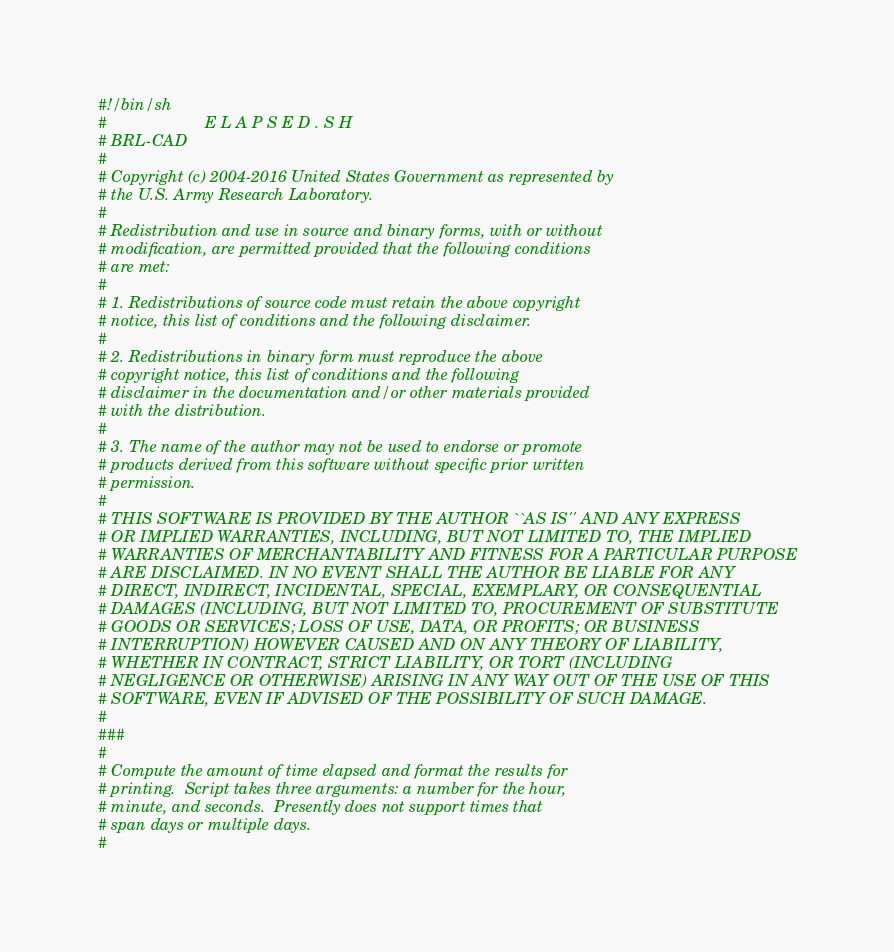Convert code to text. <code><loc_0><loc_0><loc_500><loc_500><_Bash_>#!/bin/sh
#                      E L A P S E D . S H
# BRL-CAD
#
# Copyright (c) 2004-2016 United States Government as represented by
# the U.S. Army Research Laboratory.
#
# Redistribution and use in source and binary forms, with or without
# modification, are permitted provided that the following conditions
# are met:
#
# 1. Redistributions of source code must retain the above copyright
# notice, this list of conditions and the following disclaimer.
#
# 2. Redistributions in binary form must reproduce the above
# copyright notice, this list of conditions and the following
# disclaimer in the documentation and/or other materials provided
# with the distribution.
#
# 3. The name of the author may not be used to endorse or promote
# products derived from this software without specific prior written
# permission.
#
# THIS SOFTWARE IS PROVIDED BY THE AUTHOR ``AS IS'' AND ANY EXPRESS
# OR IMPLIED WARRANTIES, INCLUDING, BUT NOT LIMITED TO, THE IMPLIED
# WARRANTIES OF MERCHANTABILITY AND FITNESS FOR A PARTICULAR PURPOSE
# ARE DISCLAIMED. IN NO EVENT SHALL THE AUTHOR BE LIABLE FOR ANY
# DIRECT, INDIRECT, INCIDENTAL, SPECIAL, EXEMPLARY, OR CONSEQUENTIAL
# DAMAGES (INCLUDING, BUT NOT LIMITED TO, PROCUREMENT OF SUBSTITUTE
# GOODS OR SERVICES; LOSS OF USE, DATA, OR PROFITS; OR BUSINESS
# INTERRUPTION) HOWEVER CAUSED AND ON ANY THEORY OF LIABILITY,
# WHETHER IN CONTRACT, STRICT LIABILITY, OR TORT (INCLUDING
# NEGLIGENCE OR OTHERWISE) ARISING IN ANY WAY OUT OF THE USE OF THIS
# SOFTWARE, EVEN IF ADVISED OF THE POSSIBILITY OF SUCH DAMAGE.
#
###
#
# Compute the amount of time elapsed and format the results for
# printing.  Script takes three arguments: a number for the hour,
# minute, and seconds.  Presently does not support times that
# span days or multiple days.
#</code> 